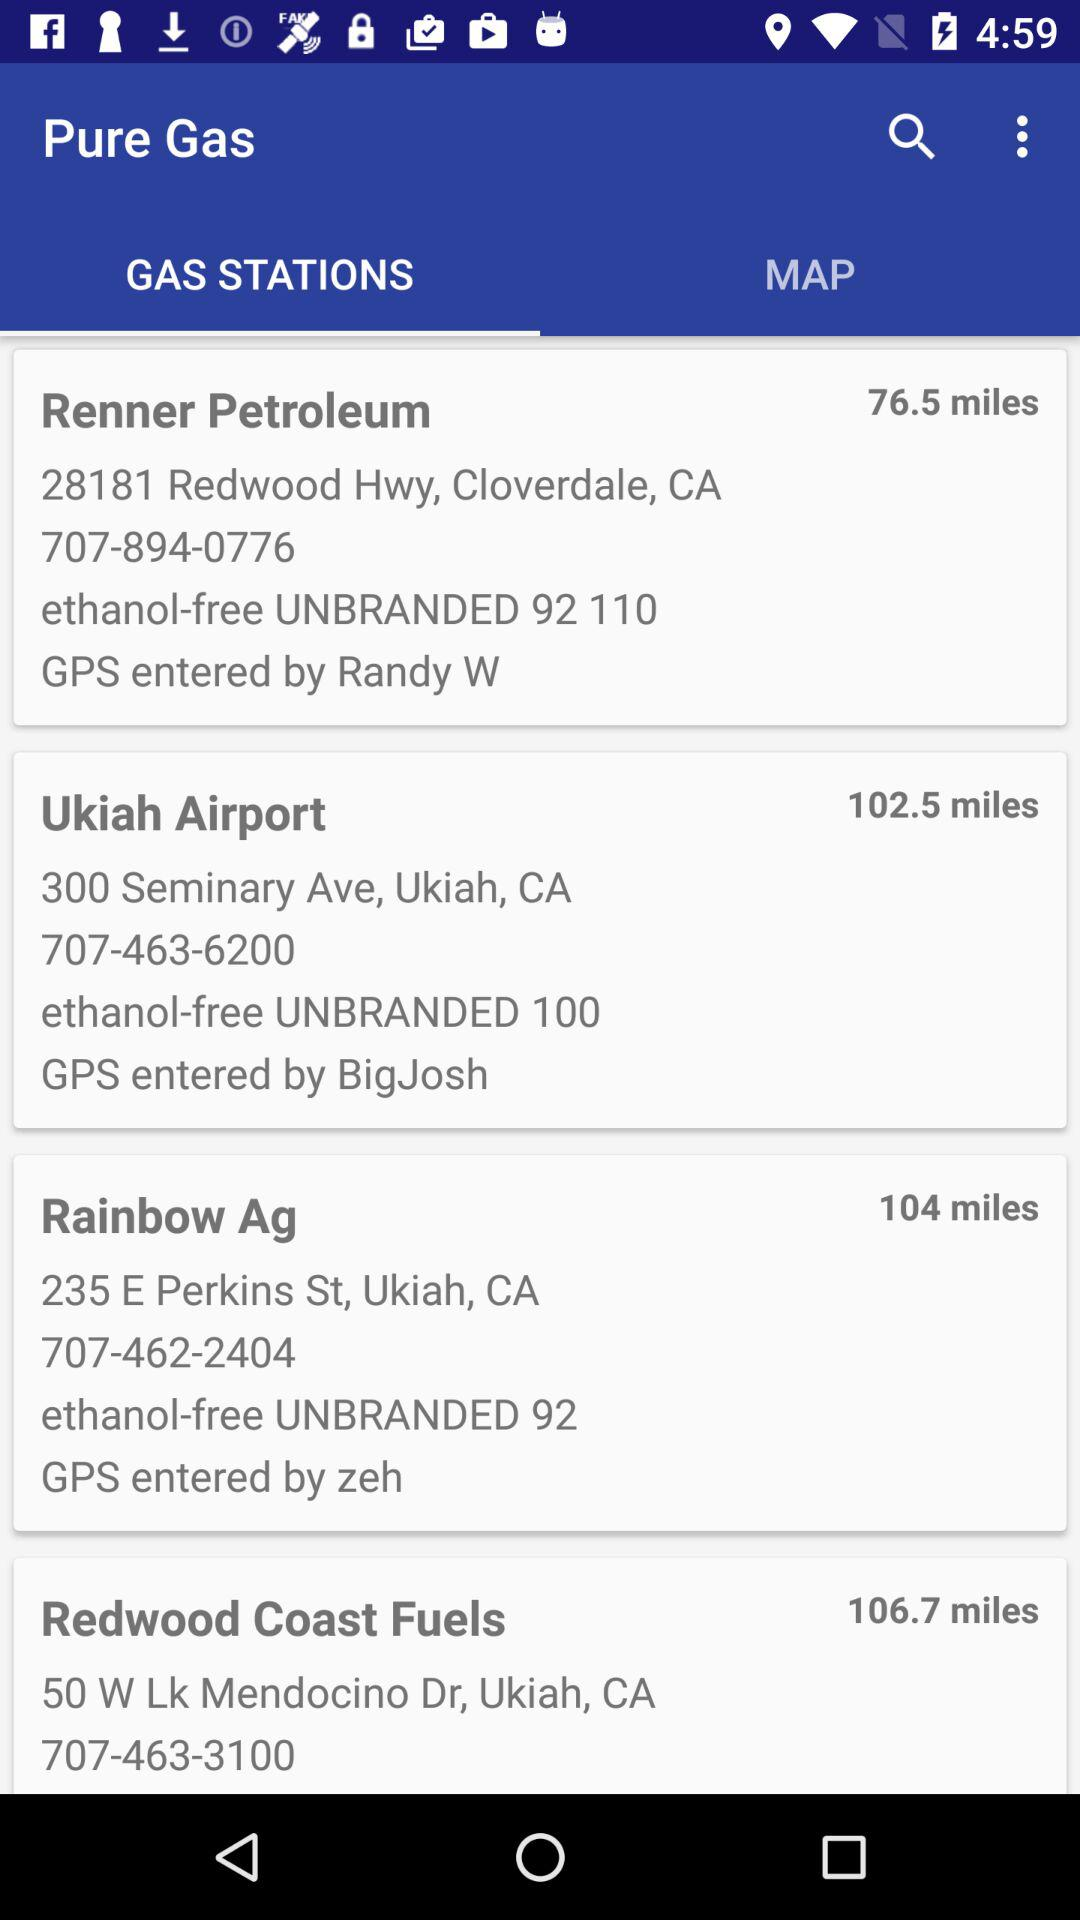What is the contact number of "Renner Petroleum"? The contact number of "Renner Petroleum" is 707-894-0776. 